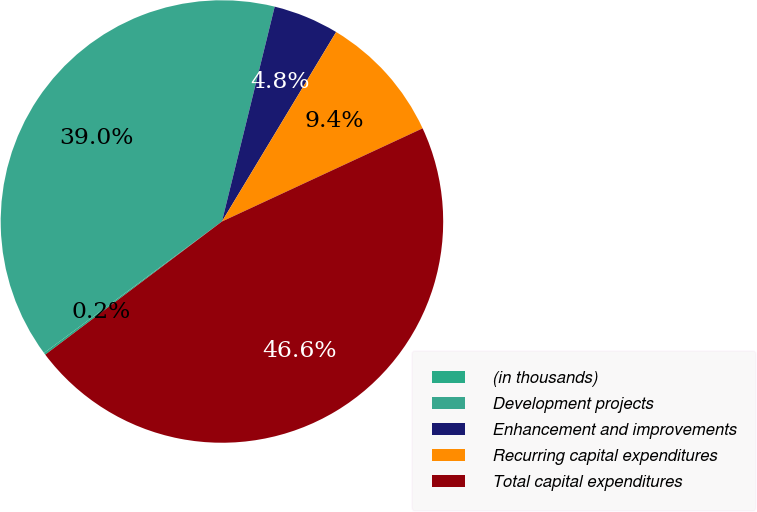<chart> <loc_0><loc_0><loc_500><loc_500><pie_chart><fcel>(in thousands)<fcel>Development projects<fcel>Enhancement and improvements<fcel>Recurring capital expenditures<fcel>Total capital expenditures<nl><fcel>0.15%<fcel>38.96%<fcel>4.8%<fcel>9.45%<fcel>46.64%<nl></chart> 